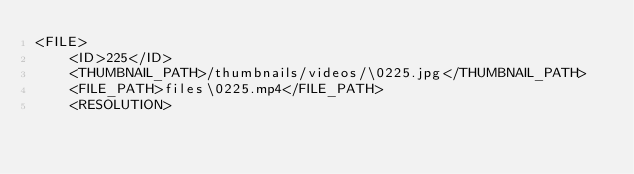<code> <loc_0><loc_0><loc_500><loc_500><_XML_><FILE>
	<ID>225</ID>
	<THUMBNAIL_PATH>/thumbnails/videos/\0225.jpg</THUMBNAIL_PATH>
	<FILE_PATH>files\0225.mp4</FILE_PATH>
	<RESOLUTION></code> 